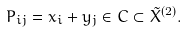<formula> <loc_0><loc_0><loc_500><loc_500>P _ { i j } = x _ { i } + y _ { j } \in C \subset \tilde { X } ^ { ( 2 ) } .</formula> 